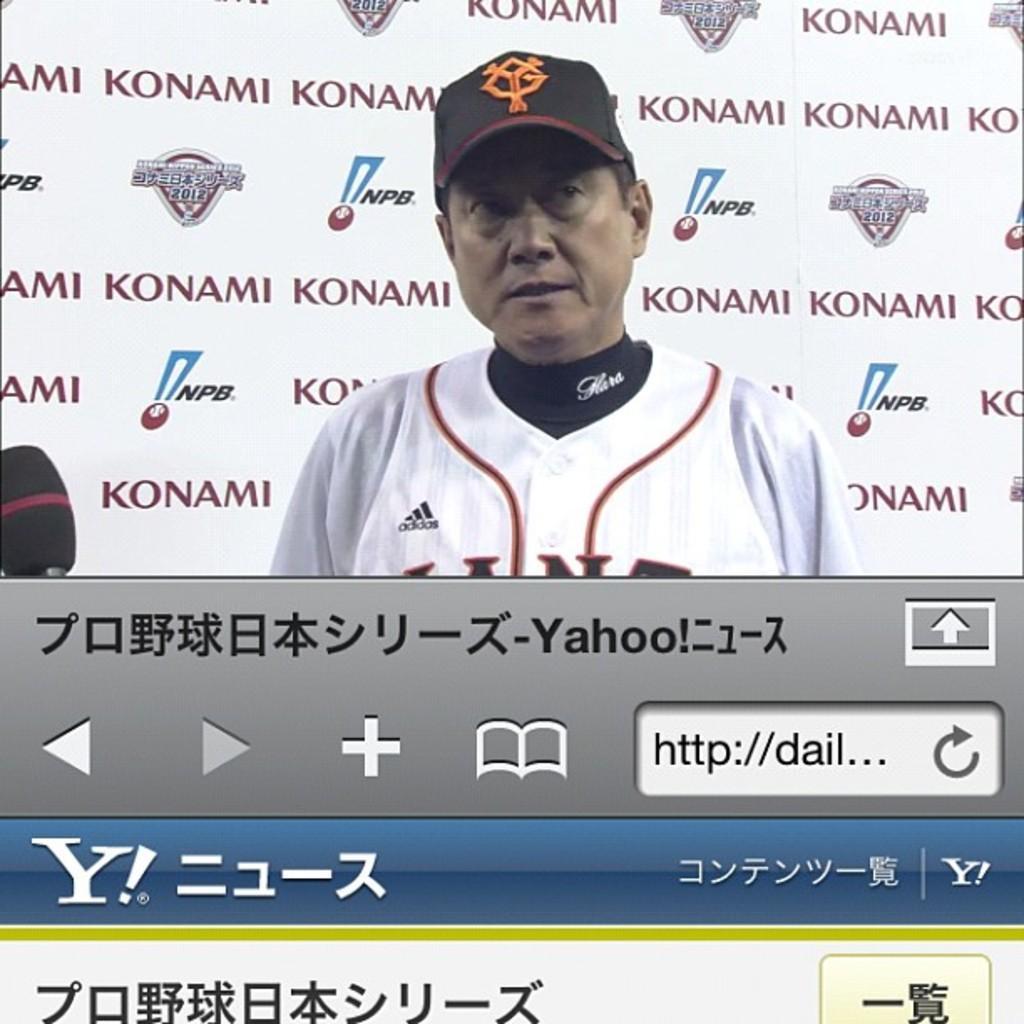Could you give a brief overview of what you see in this image? In this image we can see a person standing. Behind the person we can see some text and image in the background. At the bottom we can see a url, few buttons and some text written in Chinese. 